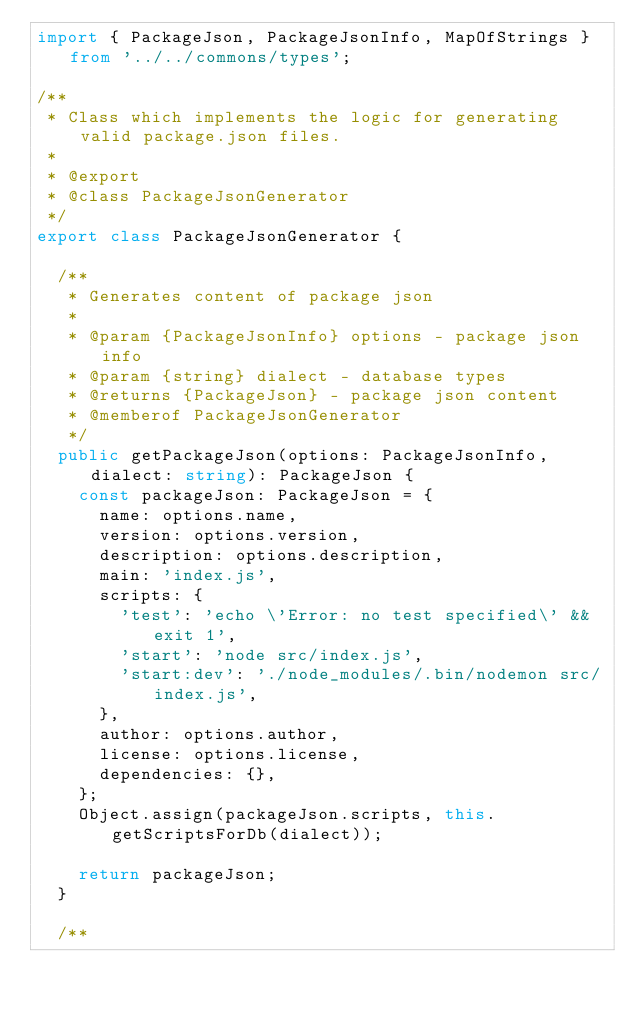Convert code to text. <code><loc_0><loc_0><loc_500><loc_500><_TypeScript_>import { PackageJson, PackageJsonInfo, MapOfStrings } from '../../commons/types';

/**
 * Class which implements the logic for generating valid package.json files.
 *
 * @export
 * @class PackageJsonGenerator
 */
export class PackageJsonGenerator {

  /**
   * Generates content of package json
   *
   * @param {PackageJsonInfo} options - package json info
   * @param {string} dialect - database types
   * @returns {PackageJson} - package json content
   * @memberof PackageJsonGenerator
   */
  public getPackageJson(options: PackageJsonInfo, dialect: string): PackageJson {
    const packageJson: PackageJson = {
      name: options.name,
      version: options.version,
      description: options.description,
      main: 'index.js',
      scripts: {
        'test': 'echo \'Error: no test specified\' && exit 1',
        'start': 'node src/index.js',
        'start:dev': './node_modules/.bin/nodemon src/index.js',
      },
      author: options.author,
      license: options.license,
      dependencies: {},
    };
    Object.assign(packageJson.scripts, this.getScriptsForDb(dialect));

    return packageJson;
  }

  /**</code> 